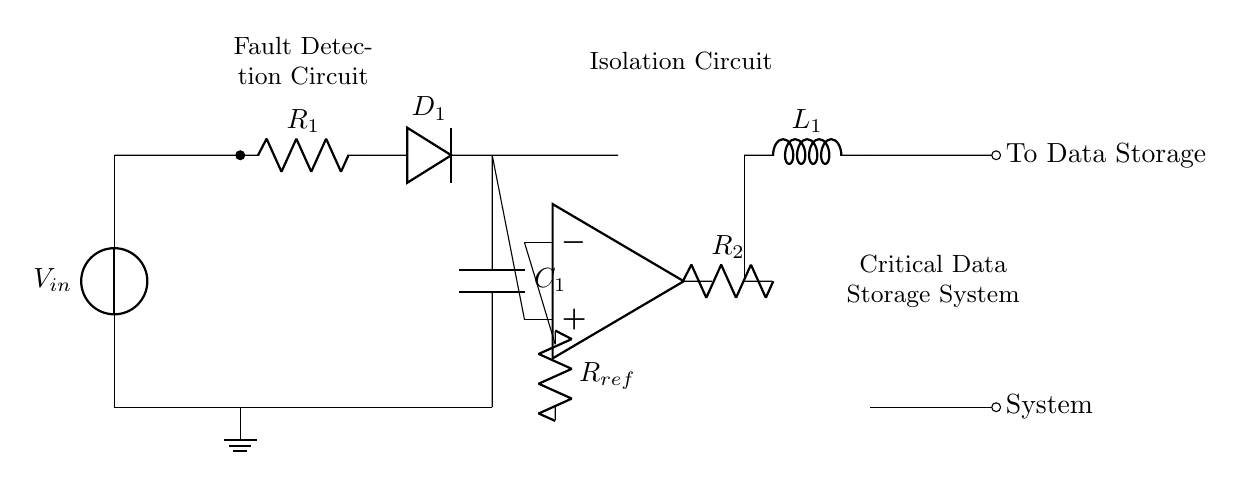What is the main function of the comparator in this circuit? The comparator compares the voltage levels at its two inputs—one from the reference resistor and the other from the fault detection circuit. Based on this comparison, it outputs a signal that indicates the presence of a fault.
Answer: Fault detection What component is used to connect the output from the comparator to the isolation circuit? The output from the comparator is connected to the isolation circuit through a resistor, labeled as R2. This component helps ensure that any fault signal is relayed effectively to the next stage of the circuit.
Answer: Resistor What type of component is used for fault detection? A diode is employed in the fault detection circuit (D1), which allows current to flow in one direction, helping to identify any anomalies that could indicate a fault.
Answer: Diode Which component provides isolation for the critical data storage system? The isolation circuit contains a PNP transistor, which acts as a switch to control power delivery to the data storage system based on the signal received from the comparator.
Answer: PNP transistor What happens to the data storage system if a fault is detected? If a fault is detected, the output from the isolation circuit will change, leading to the disconnection or modification of power supplied to the data storage system, thus protecting its integrity.
Answer: Disconnection Which component in the circuit is responsible for smoothing voltage fluctuations? The capacitor, labeled C1, is responsible for smoothing out voltage fluctuations caused by abrupt changes in the circuit, providing a more stable voltage supply to the fault detection circuit.
Answer: Capacitor 